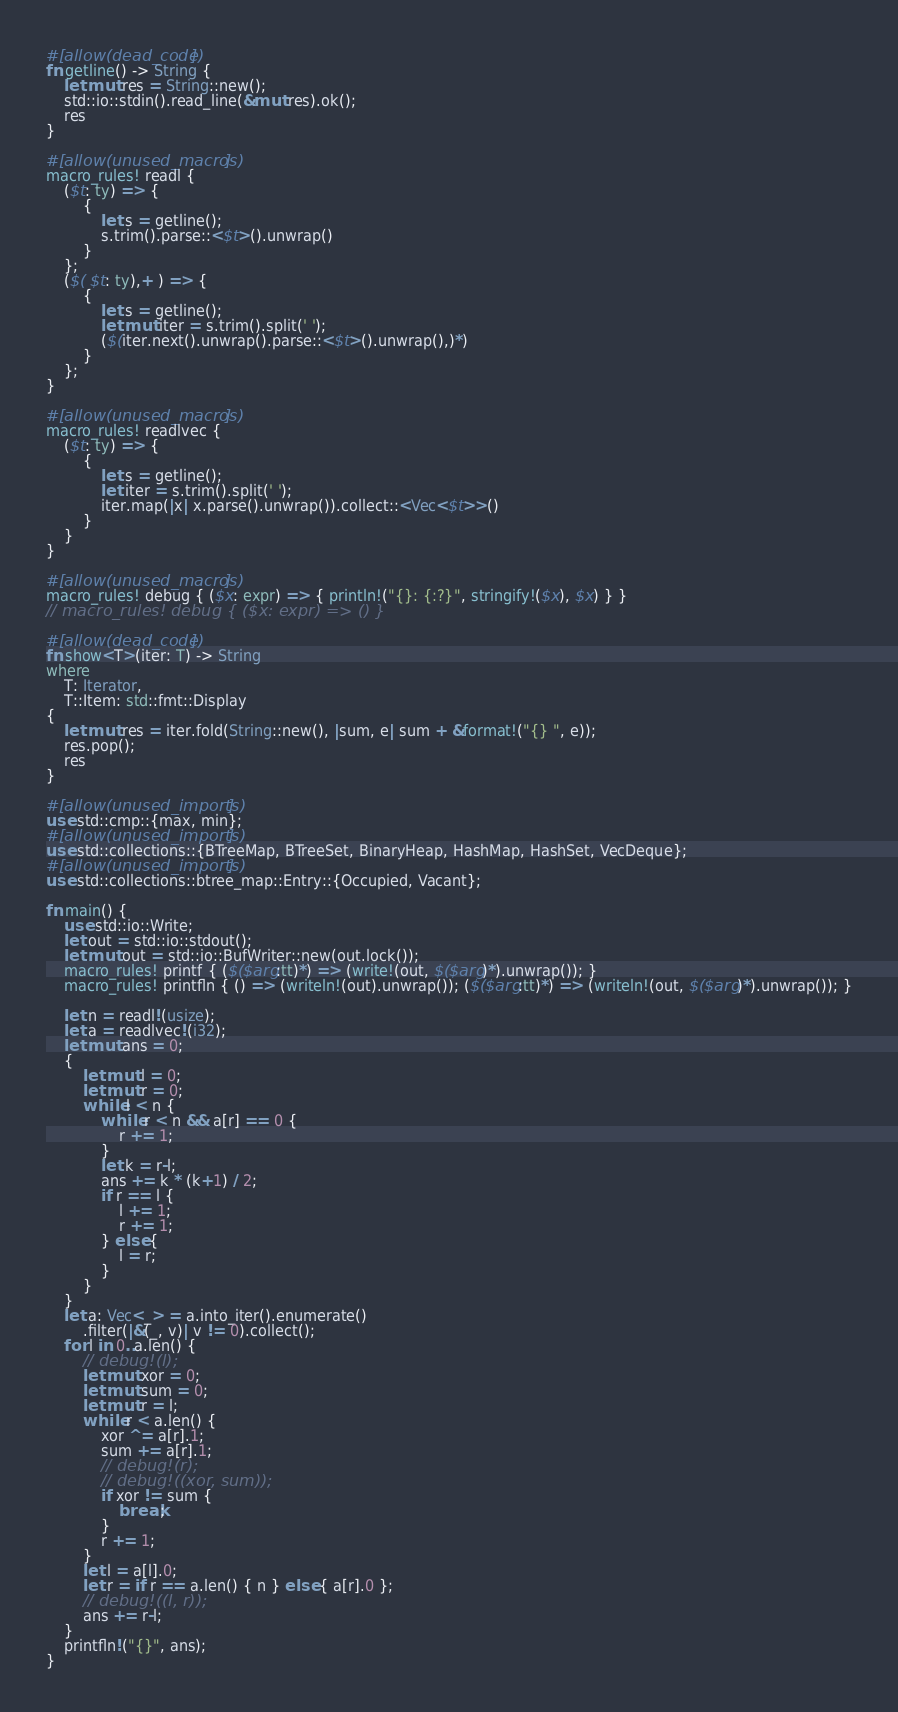Convert code to text. <code><loc_0><loc_0><loc_500><loc_500><_Rust_>#[allow(dead_code)]
fn getline() -> String {
    let mut res = String::new();
    std::io::stdin().read_line(&mut res).ok();
    res
}

#[allow(unused_macros)]
macro_rules! readl {
    ($t: ty) => {
        {
            let s = getline();
            s.trim().parse::<$t>().unwrap()
        }
    };
    ($( $t: ty),+ ) => {
        {
            let s = getline();
            let mut iter = s.trim().split(' ');
            ($(iter.next().unwrap().parse::<$t>().unwrap(),)*)
        }
    };
}

#[allow(unused_macros)]
macro_rules! readlvec {
    ($t: ty) => {
        {
            let s = getline();
            let iter = s.trim().split(' ');
            iter.map(|x| x.parse().unwrap()).collect::<Vec<$t>>()
        }
    }
}

#[allow(unused_macros)]
macro_rules! debug { ($x: expr) => { println!("{}: {:?}", stringify!($x), $x) } }
// macro_rules! debug { ($x: expr) => () }

#[allow(dead_code)]
fn show<T>(iter: T) -> String
where
    T: Iterator,
    T::Item: std::fmt::Display
{
    let mut res = iter.fold(String::new(), |sum, e| sum + &format!("{} ", e));
    res.pop();
    res
}

#[allow(unused_imports)]
use std::cmp::{max, min};
#[allow(unused_imports)]
use std::collections::{BTreeMap, BTreeSet, BinaryHeap, HashMap, HashSet, VecDeque};
#[allow(unused_imports)]
use std::collections::btree_map::Entry::{Occupied, Vacant};

fn main() {
    use std::io::Write;
    let out = std::io::stdout();
    let mut out = std::io::BufWriter::new(out.lock());
    macro_rules! printf { ($($arg:tt)*) => (write!(out, $($arg)*).unwrap()); }
    macro_rules! printfln { () => (writeln!(out).unwrap()); ($($arg:tt)*) => (writeln!(out, $($arg)*).unwrap()); }
    
    let n = readl!(usize);
    let a = readlvec!(i32);
    let mut ans = 0;
    {
        let mut l = 0;
        let mut r = 0;
        while l < n {
            while r < n && a[r] == 0 {
                r += 1;
            }
            let k = r-l;
            ans += k * (k+1) / 2;
            if r == l {
                l += 1;
                r += 1;
            } else {
                l = r;
            }
        }
    }
    let a: Vec<_> = a.into_iter().enumerate()
        .filter(|&(_, v)| v != 0).collect();
    for l in 0..a.len() {
        // debug!(l);
        let mut xor = 0;
        let mut sum = 0;
        let mut r = l;
        while r < a.len() {
            xor ^= a[r].1;
            sum += a[r].1;
            // debug!(r);
            // debug!((xor, sum));
            if xor != sum {
                break;
            }
            r += 1;
        }
        let l = a[l].0;
        let r = if r == a.len() { n } else { a[r].0 };
        // debug!((l, r));
        ans += r-l;
    }
    printfln!("{}", ans);
}
</code> 